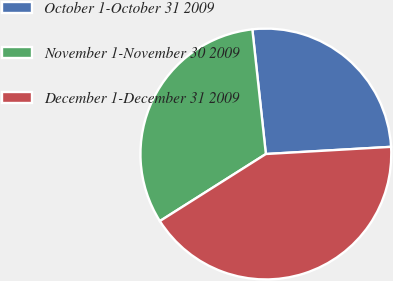<chart> <loc_0><loc_0><loc_500><loc_500><pie_chart><fcel>October 1-October 31 2009<fcel>November 1-November 30 2009<fcel>December 1-December 31 2009<nl><fcel>25.81%<fcel>32.26%<fcel>41.94%<nl></chart> 